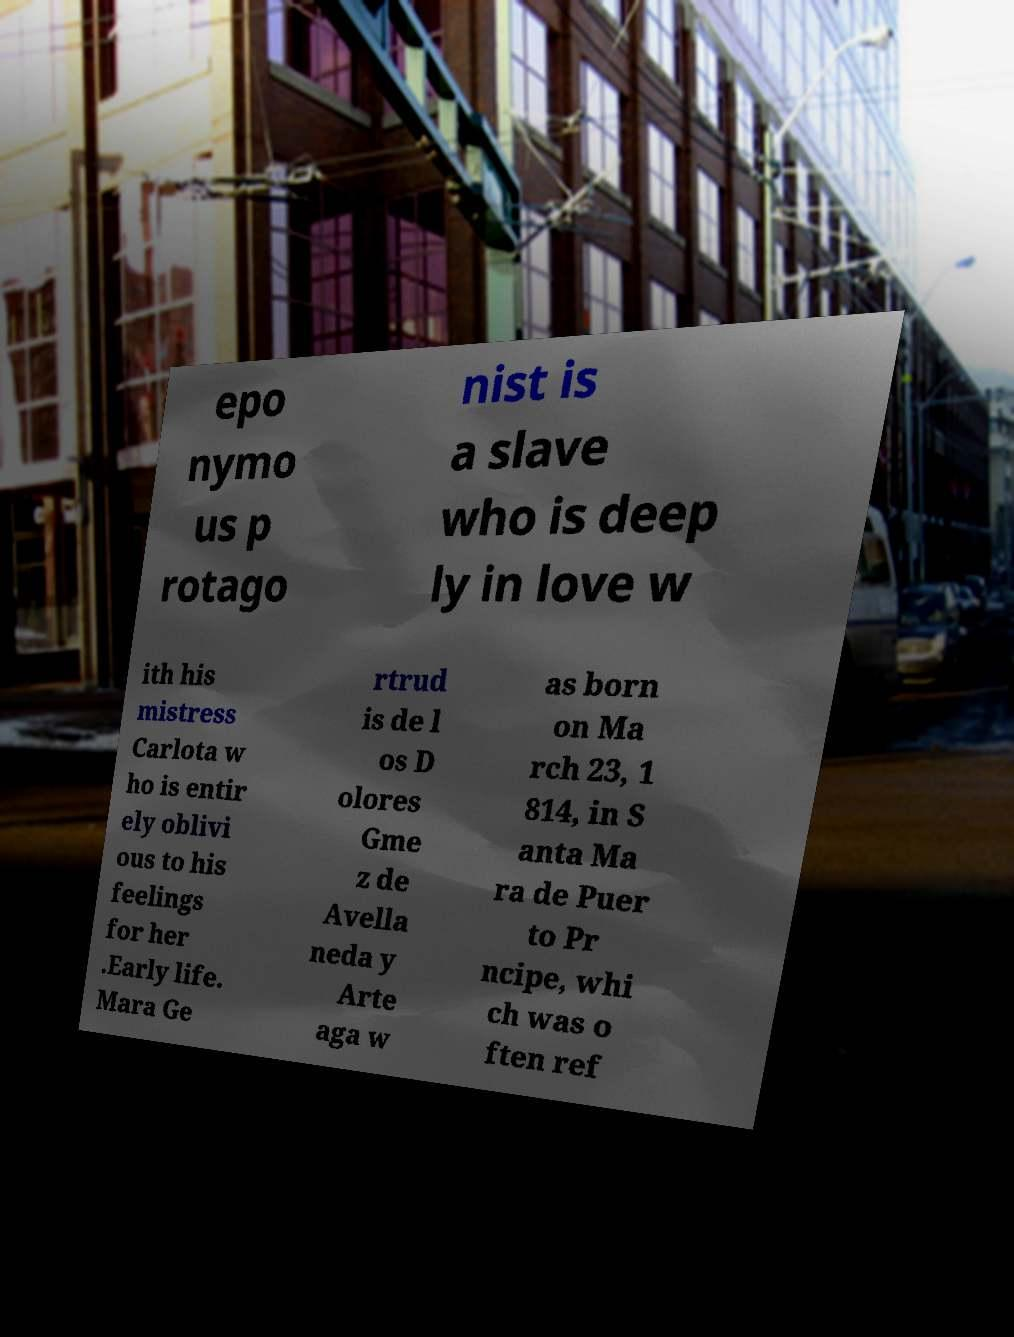Could you extract and type out the text from this image? epo nymo us p rotago nist is a slave who is deep ly in love w ith his mistress Carlota w ho is entir ely oblivi ous to his feelings for her .Early life. Mara Ge rtrud is de l os D olores Gme z de Avella neda y Arte aga w as born on Ma rch 23, 1 814, in S anta Ma ra de Puer to Pr ncipe, whi ch was o ften ref 